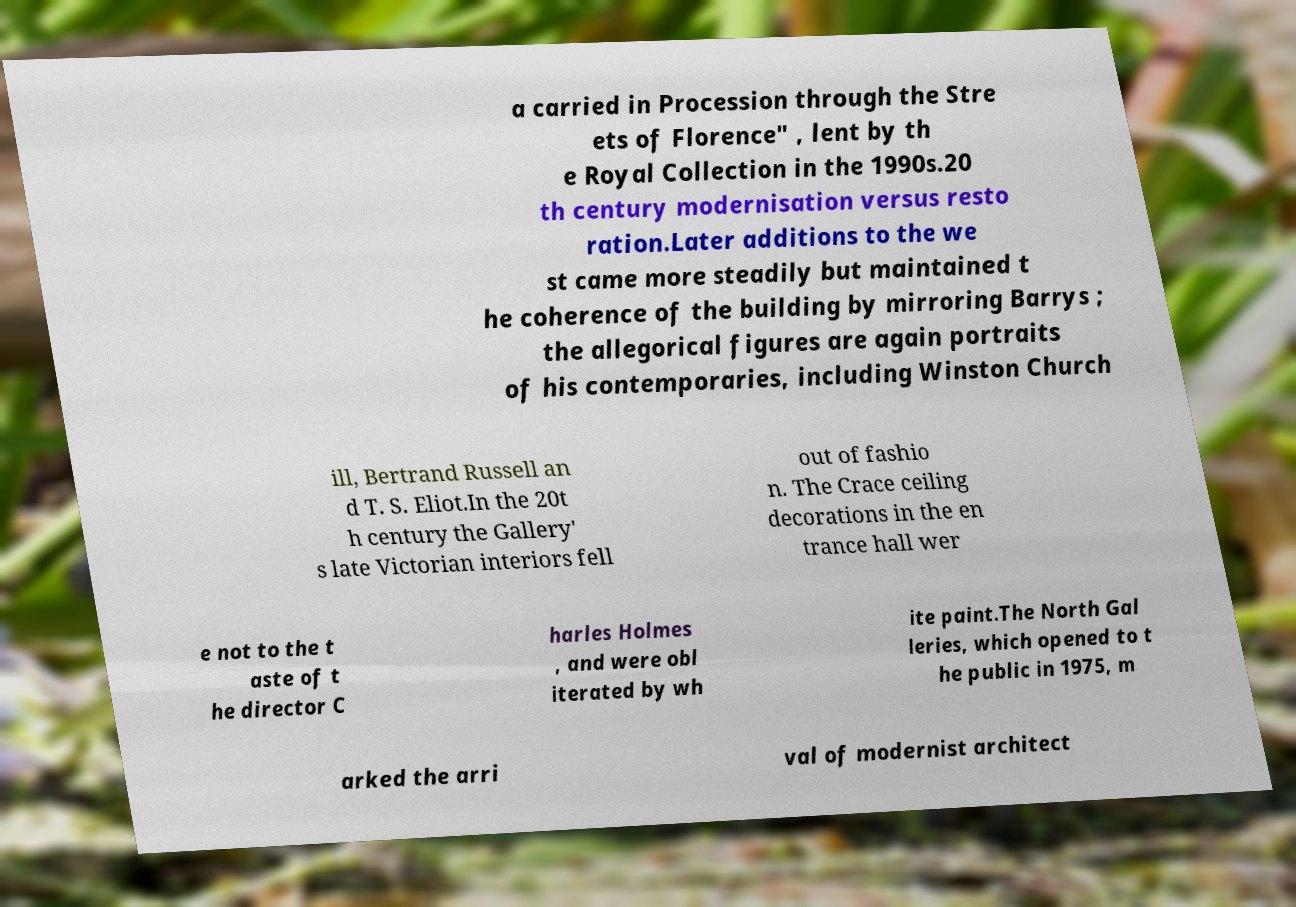Please read and relay the text visible in this image. What does it say? a carried in Procession through the Stre ets of Florence" , lent by th e Royal Collection in the 1990s.20 th century modernisation versus resto ration.Later additions to the we st came more steadily but maintained t he coherence of the building by mirroring Barrys ; the allegorical figures are again portraits of his contemporaries, including Winston Church ill, Bertrand Russell an d T. S. Eliot.In the 20t h century the Gallery' s late Victorian interiors fell out of fashio n. The Crace ceiling decorations in the en trance hall wer e not to the t aste of t he director C harles Holmes , and were obl iterated by wh ite paint.The North Gal leries, which opened to t he public in 1975, m arked the arri val of modernist architect 